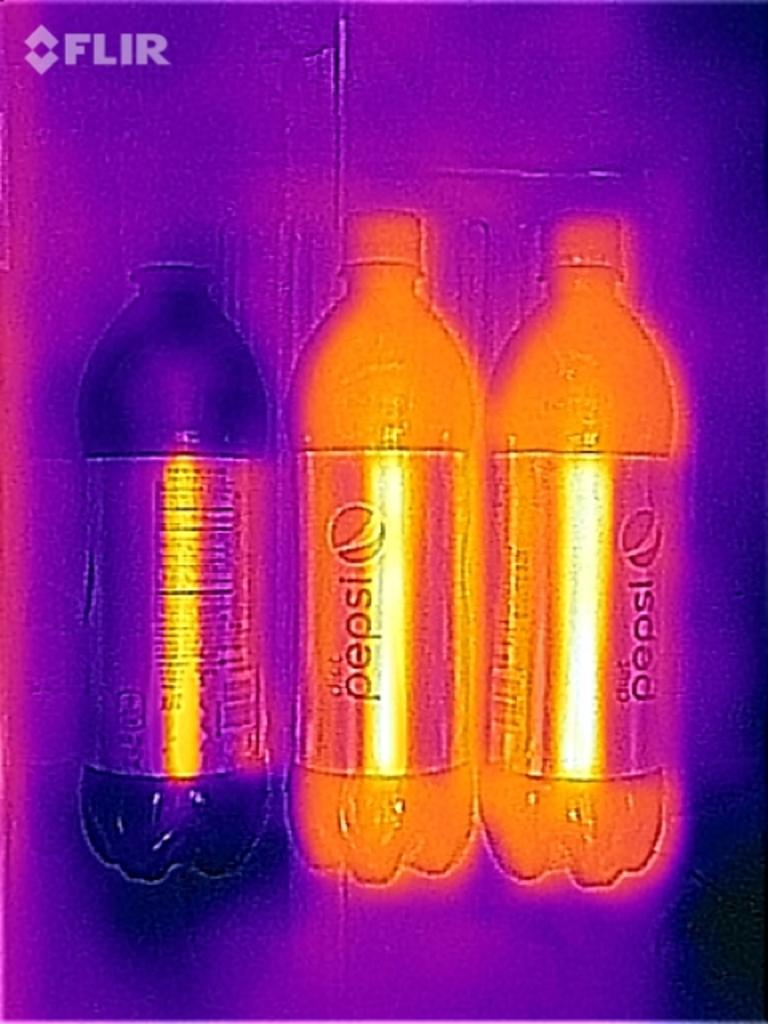<image>
Present a compact description of the photo's key features. Three plastic bottles of pepsi are in unusual lighting. 